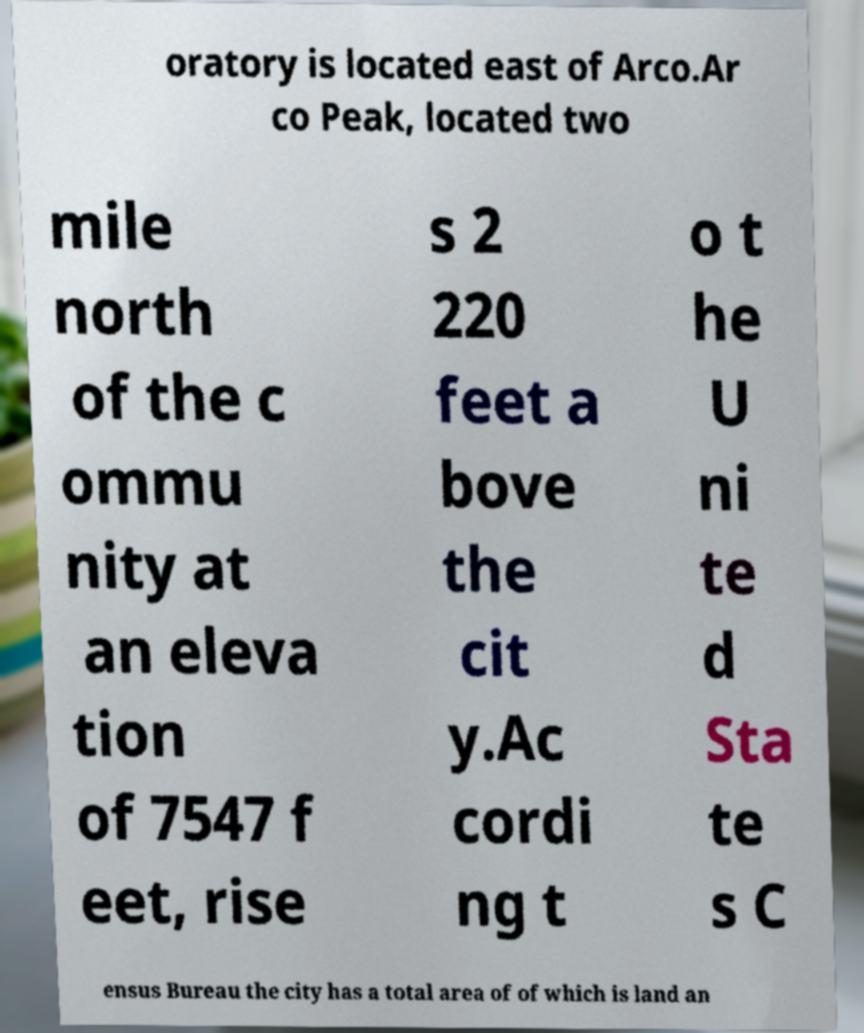Please identify and transcribe the text found in this image. oratory is located east of Arco.Ar co Peak, located two mile north of the c ommu nity at an eleva tion of 7547 f eet, rise s 2 220 feet a bove the cit y.Ac cordi ng t o t he U ni te d Sta te s C ensus Bureau the city has a total area of of which is land an 